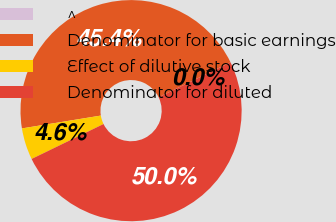Convert chart. <chart><loc_0><loc_0><loc_500><loc_500><pie_chart><fcel>^<fcel>Denominator for basic earnings<fcel>Effect of dilutive stock<fcel>Denominator for diluted<nl><fcel>0.0%<fcel>45.37%<fcel>4.63%<fcel>50.0%<nl></chart> 